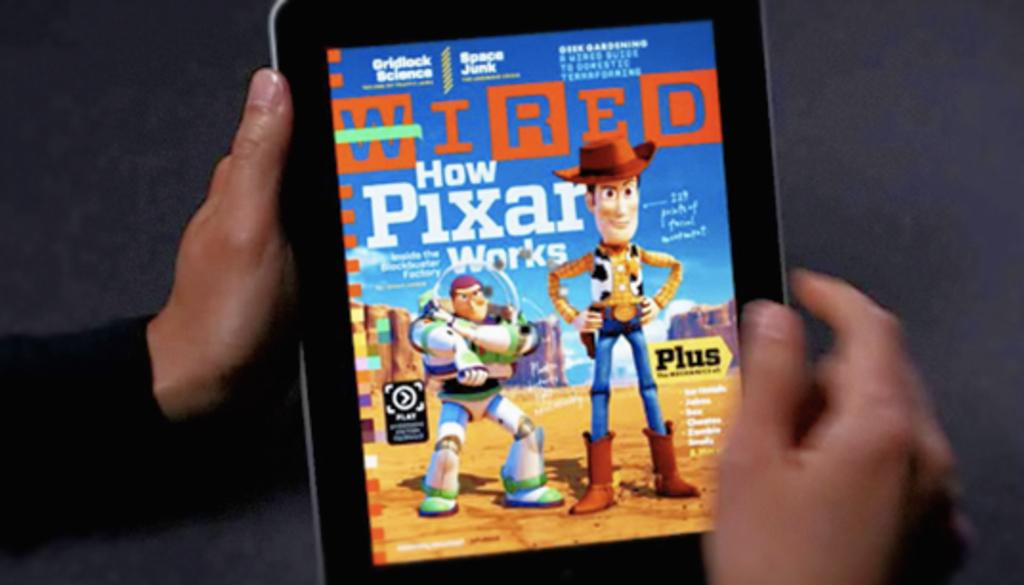<image>
Relay a brief, clear account of the picture shown. Wired Magazine did an article about the technology behind Pixar movies. 